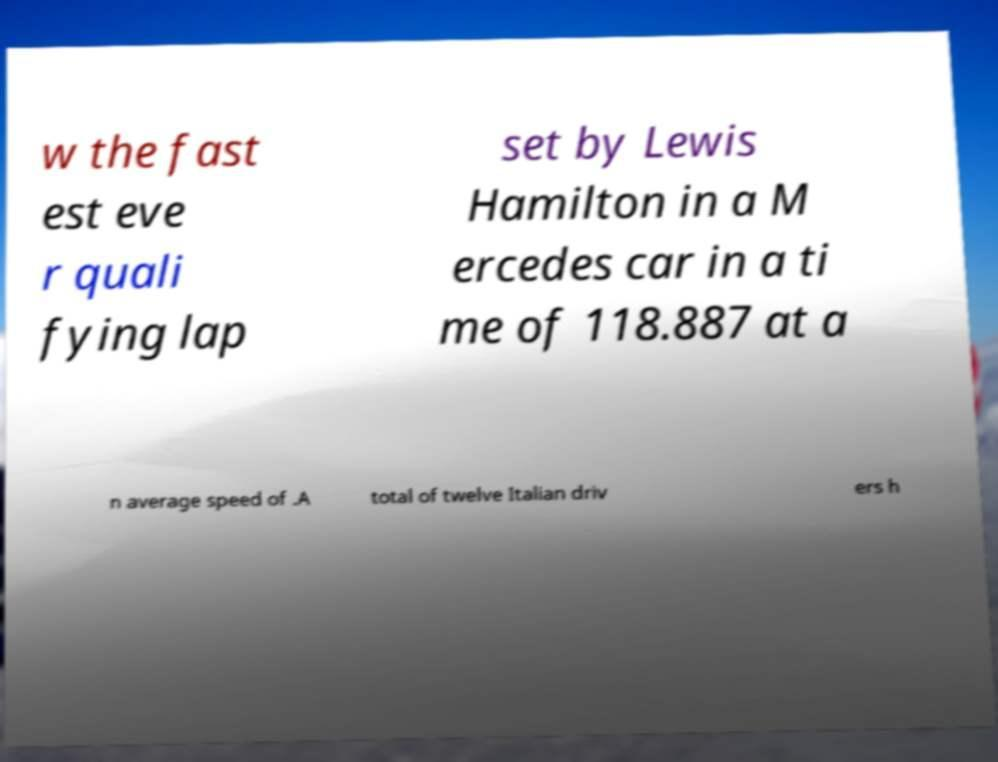Please identify and transcribe the text found in this image. w the fast est eve r quali fying lap set by Lewis Hamilton in a M ercedes car in a ti me of 118.887 at a n average speed of .A total of twelve Italian driv ers h 